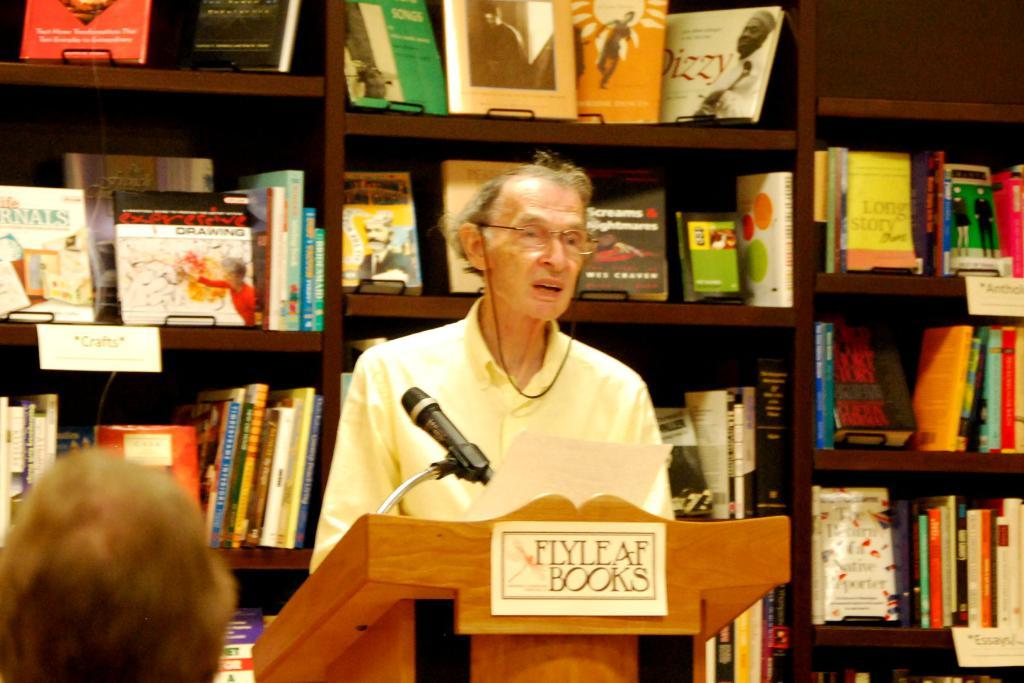<image>
Render a clear and concise summary of the photo. A speaker is at a podium with Flyleaf Books written on it. 